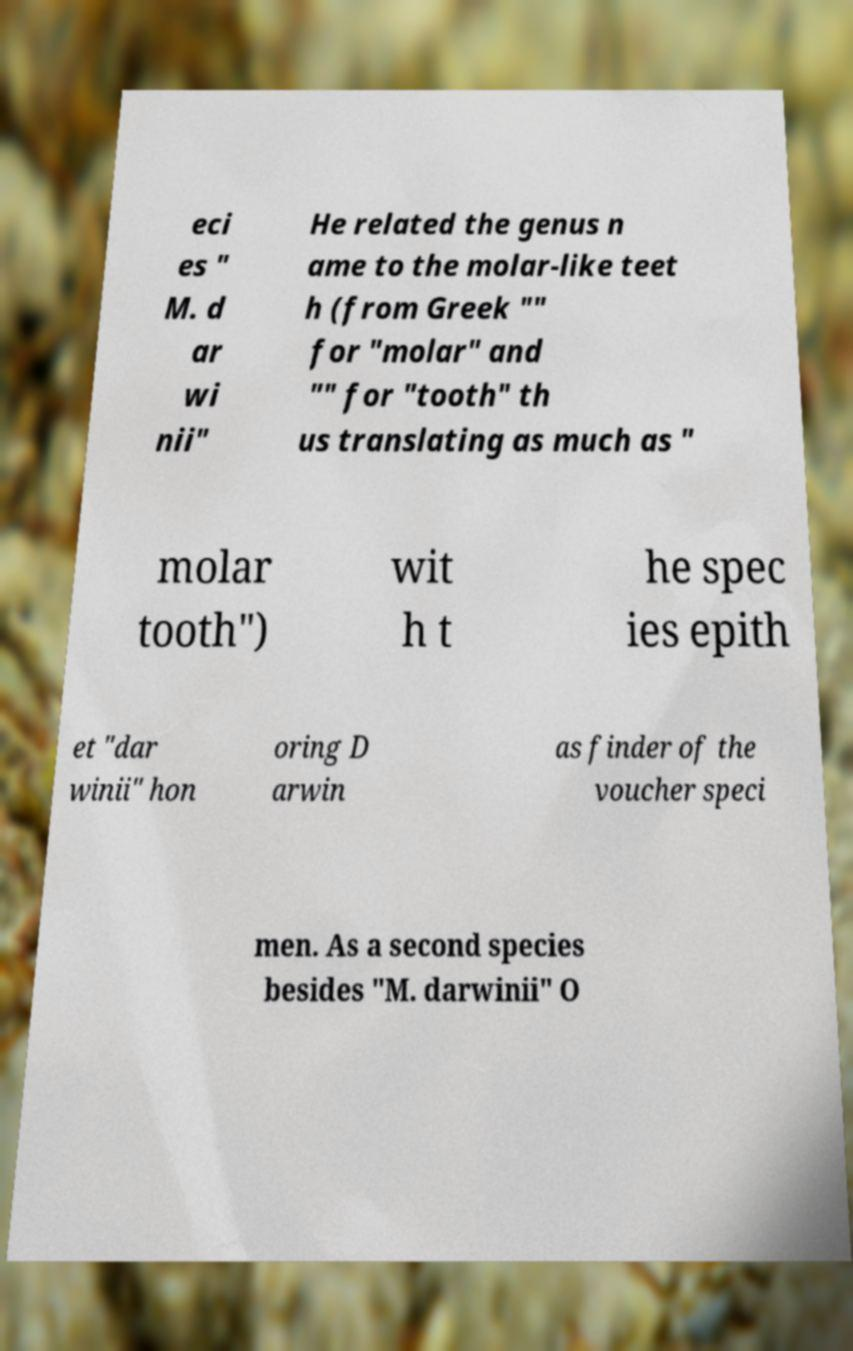Can you accurately transcribe the text from the provided image for me? eci es " M. d ar wi nii" He related the genus n ame to the molar-like teet h (from Greek "" for "molar" and "" for "tooth" th us translating as much as " molar tooth") wit h t he spec ies epith et "dar winii" hon oring D arwin as finder of the voucher speci men. As a second species besides "M. darwinii" O 